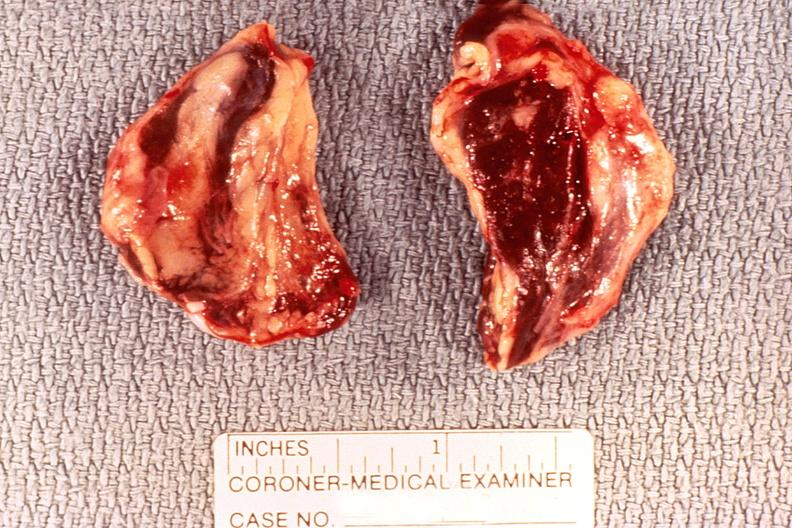s endocrine present?
Answer the question using a single word or phrase. Yes 